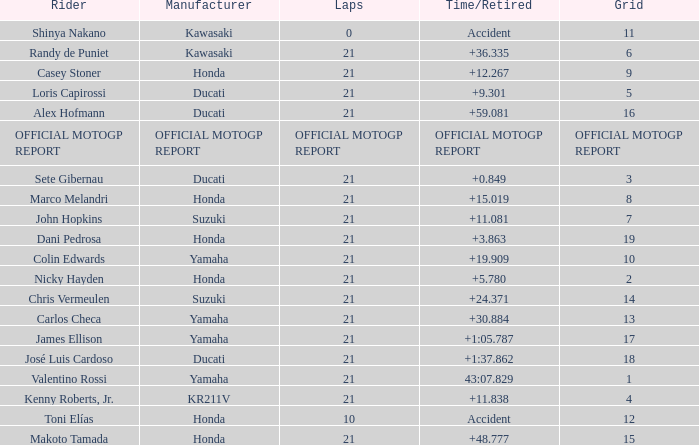WWhich rder had a vehicle manufactured by kr211v? Kenny Roberts, Jr. 